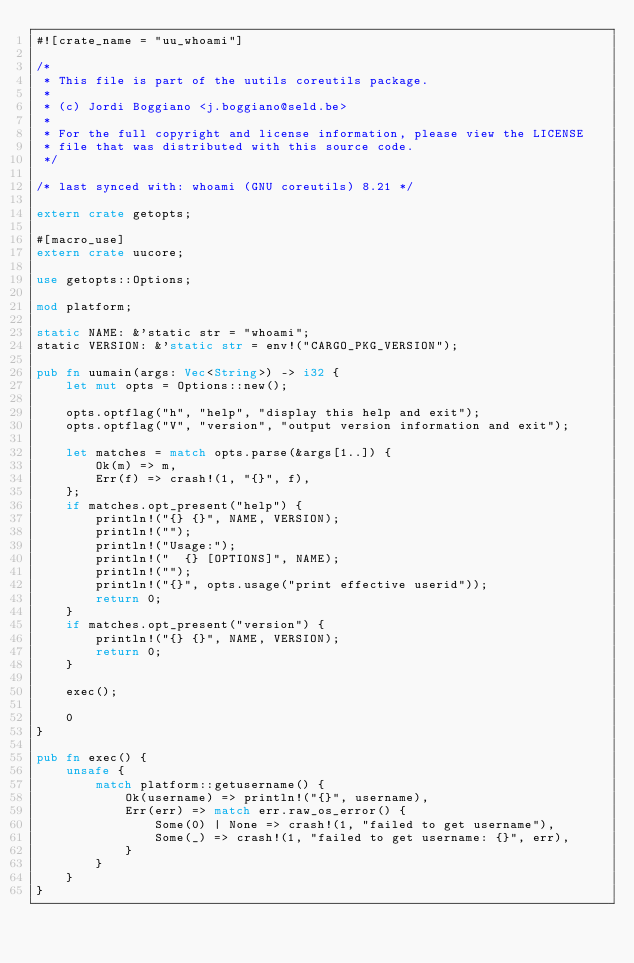Convert code to text. <code><loc_0><loc_0><loc_500><loc_500><_Rust_>#![crate_name = "uu_whoami"]

/*
 * This file is part of the uutils coreutils package.
 *
 * (c) Jordi Boggiano <j.boggiano@seld.be>
 *
 * For the full copyright and license information, please view the LICENSE
 * file that was distributed with this source code.
 */

/* last synced with: whoami (GNU coreutils) 8.21 */

extern crate getopts;

#[macro_use]
extern crate uucore;

use getopts::Options;

mod platform;

static NAME: &'static str = "whoami";
static VERSION: &'static str = env!("CARGO_PKG_VERSION");

pub fn uumain(args: Vec<String>) -> i32 {
    let mut opts = Options::new();

    opts.optflag("h", "help", "display this help and exit");
    opts.optflag("V", "version", "output version information and exit");

    let matches = match opts.parse(&args[1..]) {
        Ok(m) => m,
        Err(f) => crash!(1, "{}", f),
    };
    if matches.opt_present("help") {
        println!("{} {}", NAME, VERSION);
        println!("");
        println!("Usage:");
        println!("  {} [OPTIONS]", NAME);
        println!("");
        println!("{}", opts.usage("print effective userid"));
        return 0;
    }
    if matches.opt_present("version") {
        println!("{} {}", NAME, VERSION);
        return 0;
    }

    exec();

    0
}

pub fn exec() {
    unsafe {
        match platform::getusername() {
            Ok(username) => println!("{}", username),
            Err(err) => match err.raw_os_error() {
                Some(0) | None => crash!(1, "failed to get username"),
                Some(_) => crash!(1, "failed to get username: {}", err),
            }
        }
    }
}
</code> 